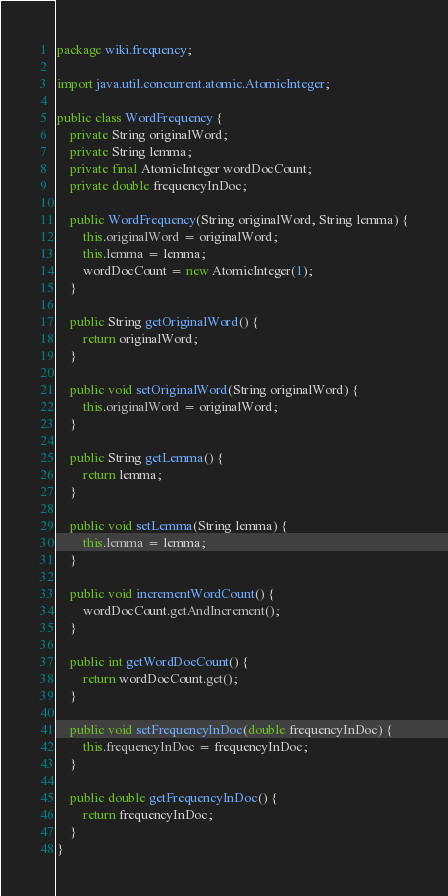Convert code to text. <code><loc_0><loc_0><loc_500><loc_500><_Java_>package wiki.frequency;

import java.util.concurrent.atomic.AtomicInteger;

public class WordFrequency {
    private String originalWord;
    private String lemma;
    private final AtomicInteger wordDocCount;
    private double frequencyInDoc;

    public WordFrequency(String originalWord, String lemma) {
        this.originalWord = originalWord;
        this.lemma = lemma;
        wordDocCount = new AtomicInteger(1);
    }

    public String getOriginalWord() {
        return originalWord;
    }

    public void setOriginalWord(String originalWord) {
        this.originalWord = originalWord;
    }

    public String getLemma() {
        return lemma;
    }

    public void setLemma(String lemma) {
        this.lemma = lemma;
    }

    public void incrementWordCount() {
        wordDocCount.getAndIncrement();
    }

    public int getWordDocCount() {
        return wordDocCount.get();
    }

    public void setFrequencyInDoc(double frequencyInDoc) {
        this.frequencyInDoc = frequencyInDoc;
    }

    public double getFrequencyInDoc() {
        return frequencyInDoc;
    }
}
</code> 